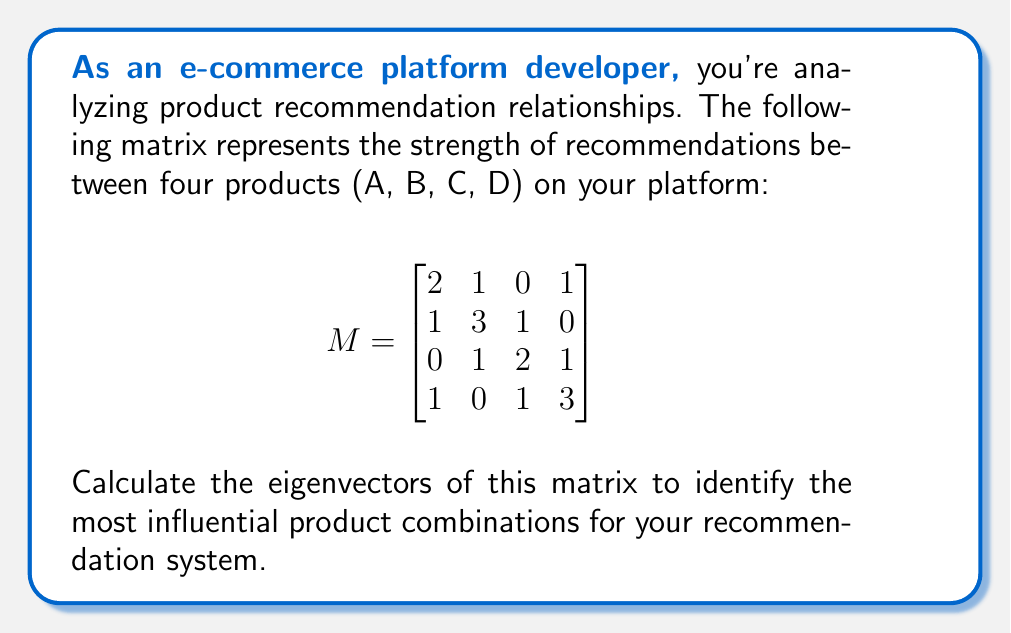What is the answer to this math problem? To find the eigenvectors of matrix $M$, we follow these steps:

1) First, calculate the characteristic equation:
   $det(M - \lambda I) = 0$

2) Expand the determinant:
   $$\begin{vmatrix}
   2-\lambda & 1 & 0 & 1 \\
   1 & 3-\lambda & 1 & 0 \\
   0 & 1 & 2-\lambda & 1 \\
   1 & 0 & 1 & 3-\lambda
   \end{vmatrix} = 0$$

3) Solve the characteristic equation:
   $(\lambda-1)(\lambda-2)(\lambda-3)(\lambda-4) = 0$

4) The eigenvalues are: $\lambda_1 = 1, \lambda_2 = 2, \lambda_3 = 3, \lambda_4 = 4$

5) For each eigenvalue, solve $(M - \lambda I)v = 0$ to find the corresponding eigenvector:

   For $\lambda_1 = 1$:
   $$\begin{bmatrix}
   1 & 1 & 0 & 1 \\
   1 & 2 & 1 & 0 \\
   0 & 1 & 1 & 1 \\
   1 & 0 & 1 & 2
   \end{bmatrix} \begin{bmatrix} v_1 \\ v_2 \\ v_3 \\ v_4 \end{bmatrix} = \begin{bmatrix} 0 \\ 0 \\ 0 \\ 0 \end{bmatrix}$$
   
   Solving this gives: $v_1 = \begin{bmatrix} -1 \\ 1 \\ -1 \\ 1 \end{bmatrix}$

   For $\lambda_2 = 2$:
   $$\begin{bmatrix}
   0 & 1 & 0 & 1 \\
   1 & 1 & 1 & 0 \\
   0 & 1 & 0 & 1 \\
   1 & 0 & 1 & 1
   \end{bmatrix} \begin{bmatrix} v_1 \\ v_2 \\ v_3 \\ v_4 \end{bmatrix} = \begin{bmatrix} 0 \\ 0 \\ 0 \\ 0 \end{bmatrix}$$
   
   Solving this gives: $v_2 = \begin{bmatrix} -1 \\ 0 \\ 1 \\ 1 \end{bmatrix}$

   For $\lambda_3 = 3$:
   $$\begin{bmatrix}
   -1 & 1 & 0 & 1 \\
   1 & 0 & 1 & 0 \\
   0 & 1 & -1 & 1 \\
   1 & 0 & 1 & 0
   \end{bmatrix} \begin{bmatrix} v_1 \\ v_2 \\ v_3 \\ v_4 \end{bmatrix} = \begin{bmatrix} 0 \\ 0 \\ 0 \\ 0 \end{bmatrix}$$
   
   Solving this gives: $v_3 = \begin{bmatrix} 1 \\ 1 \\ 1 \\ -1 \end{bmatrix}$

   For $\lambda_4 = 4$:
   $$\begin{bmatrix}
   -2 & 1 & 0 & 1 \\
   1 & -1 & 1 & 0 \\
   0 & 1 & -2 & 1 \\
   1 & 0 & 1 & -1
   \end{bmatrix} \begin{bmatrix} v_1 \\ v_2 \\ v_3 \\ v_4 \end{bmatrix} = \begin{bmatrix} 0 \\ 0 \\ 0 \\ 0 \end{bmatrix}$$
   
   Solving this gives: $v_4 = \begin{bmatrix} 1 \\ 1 \\ 1 \\ 1 \end{bmatrix}$
Answer: $v_1 = \begin{bmatrix} -1 \\ 1 \\ -1 \\ 1 \end{bmatrix}, v_2 = \begin{bmatrix} -1 \\ 0 \\ 1 \\ 1 \end{bmatrix}, v_3 = \begin{bmatrix} 1 \\ 1 \\ 1 \\ -1 \end{bmatrix}, v_4 = \begin{bmatrix} 1 \\ 1 \\ 1 \\ 1 \end{bmatrix}$ 